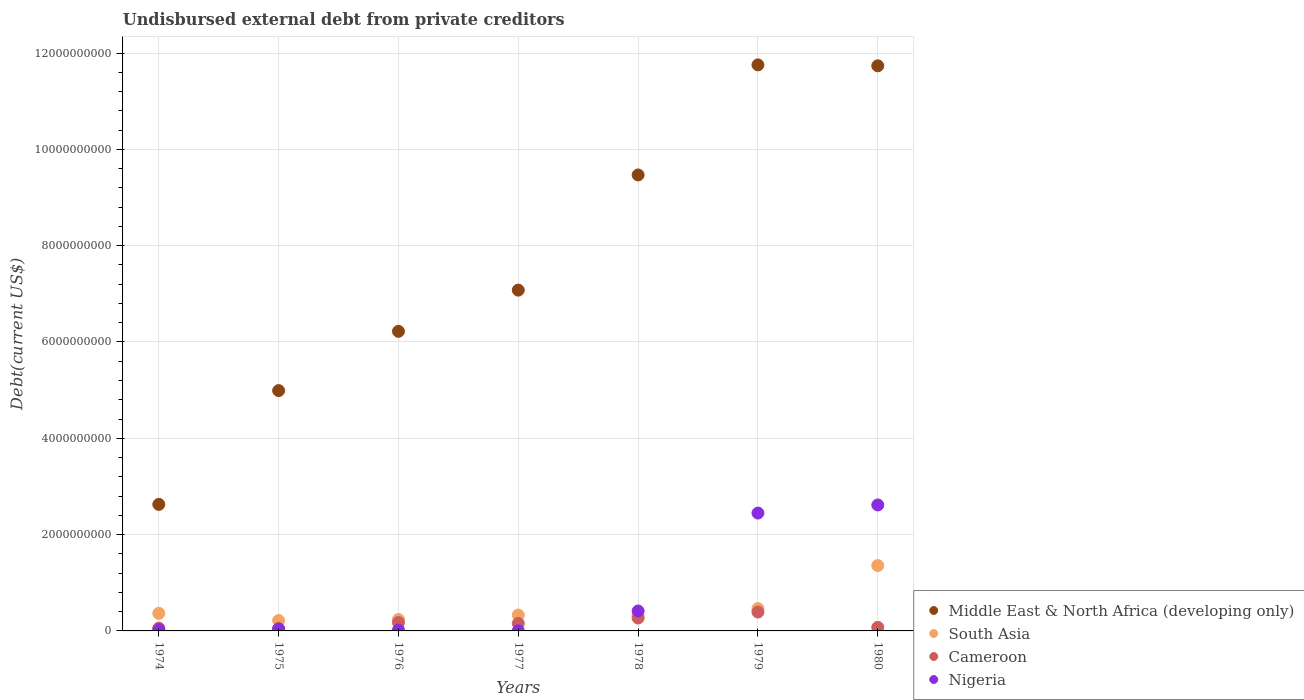How many different coloured dotlines are there?
Give a very brief answer. 4. Is the number of dotlines equal to the number of legend labels?
Ensure brevity in your answer.  Yes. What is the total debt in Cameroon in 1980?
Offer a terse response. 7.37e+07. Across all years, what is the maximum total debt in Cameroon?
Ensure brevity in your answer.  3.92e+08. Across all years, what is the minimum total debt in Middle East & North Africa (developing only)?
Offer a terse response. 2.63e+09. In which year was the total debt in Middle East & North Africa (developing only) maximum?
Provide a succinct answer. 1979. In which year was the total debt in Cameroon minimum?
Your answer should be very brief. 1975. What is the total total debt in Cameroon in the graph?
Your response must be concise. 1.17e+09. What is the difference between the total debt in Nigeria in 1978 and that in 1979?
Keep it short and to the point. -2.03e+09. What is the difference between the total debt in Nigeria in 1975 and the total debt in Cameroon in 1977?
Make the answer very short. -1.15e+08. What is the average total debt in Nigeria per year?
Offer a very short reply. 7.95e+08. In the year 1975, what is the difference between the total debt in Cameroon and total debt in Middle East & North Africa (developing only)?
Offer a terse response. -4.94e+09. In how many years, is the total debt in Nigeria greater than 8000000000 US$?
Your answer should be very brief. 0. What is the ratio of the total debt in Nigeria in 1975 to that in 1976?
Keep it short and to the point. 2.23. Is the total debt in Nigeria in 1976 less than that in 1977?
Give a very brief answer. No. What is the difference between the highest and the second highest total debt in Nigeria?
Keep it short and to the point. 1.69e+08. What is the difference between the highest and the lowest total debt in Middle East & North Africa (developing only)?
Offer a terse response. 9.13e+09. In how many years, is the total debt in South Asia greater than the average total debt in South Asia taken over all years?
Provide a succinct answer. 1. Is the sum of the total debt in Nigeria in 1977 and 1979 greater than the maximum total debt in Middle East & North Africa (developing only) across all years?
Your answer should be compact. No. Is it the case that in every year, the sum of the total debt in Cameroon and total debt in South Asia  is greater than the sum of total debt in Middle East & North Africa (developing only) and total debt in Nigeria?
Offer a terse response. No. Is the total debt in Cameroon strictly greater than the total debt in South Asia over the years?
Provide a short and direct response. No. How many dotlines are there?
Your answer should be very brief. 4. How many years are there in the graph?
Keep it short and to the point. 7. Are the values on the major ticks of Y-axis written in scientific E-notation?
Give a very brief answer. No. Does the graph contain any zero values?
Your response must be concise. No. Where does the legend appear in the graph?
Provide a succinct answer. Bottom right. How are the legend labels stacked?
Your answer should be compact. Vertical. What is the title of the graph?
Offer a very short reply. Undisbursed external debt from private creditors. Does "Uzbekistan" appear as one of the legend labels in the graph?
Provide a short and direct response. No. What is the label or title of the X-axis?
Offer a terse response. Years. What is the label or title of the Y-axis?
Give a very brief answer. Debt(current US$). What is the Debt(current US$) in Middle East & North Africa (developing only) in 1974?
Your answer should be very brief. 2.63e+09. What is the Debt(current US$) of South Asia in 1974?
Provide a succinct answer. 3.65e+08. What is the Debt(current US$) of Cameroon in 1974?
Give a very brief answer. 5.78e+07. What is the Debt(current US$) in Nigeria in 1974?
Ensure brevity in your answer.  2.52e+07. What is the Debt(current US$) in Middle East & North Africa (developing only) in 1975?
Provide a short and direct response. 4.99e+09. What is the Debt(current US$) of South Asia in 1975?
Offer a terse response. 2.15e+08. What is the Debt(current US$) of Cameroon in 1975?
Keep it short and to the point. 4.65e+07. What is the Debt(current US$) of Nigeria in 1975?
Your answer should be very brief. 4.00e+07. What is the Debt(current US$) of Middle East & North Africa (developing only) in 1976?
Offer a terse response. 6.22e+09. What is the Debt(current US$) in South Asia in 1976?
Give a very brief answer. 2.38e+08. What is the Debt(current US$) in Cameroon in 1976?
Give a very brief answer. 1.75e+08. What is the Debt(current US$) of Nigeria in 1976?
Offer a terse response. 1.80e+07. What is the Debt(current US$) of Middle East & North Africa (developing only) in 1977?
Your answer should be very brief. 7.08e+09. What is the Debt(current US$) of South Asia in 1977?
Keep it short and to the point. 3.30e+08. What is the Debt(current US$) in Cameroon in 1977?
Offer a very short reply. 1.55e+08. What is the Debt(current US$) in Nigeria in 1977?
Ensure brevity in your answer.  2.79e+06. What is the Debt(current US$) of Middle East & North Africa (developing only) in 1978?
Offer a very short reply. 9.47e+09. What is the Debt(current US$) in South Asia in 1978?
Keep it short and to the point. 3.08e+08. What is the Debt(current US$) of Cameroon in 1978?
Provide a short and direct response. 2.67e+08. What is the Debt(current US$) of Nigeria in 1978?
Ensure brevity in your answer.  4.14e+08. What is the Debt(current US$) of Middle East & North Africa (developing only) in 1979?
Your response must be concise. 1.18e+1. What is the Debt(current US$) in South Asia in 1979?
Offer a very short reply. 4.63e+08. What is the Debt(current US$) of Cameroon in 1979?
Make the answer very short. 3.92e+08. What is the Debt(current US$) in Nigeria in 1979?
Offer a terse response. 2.45e+09. What is the Debt(current US$) in Middle East & North Africa (developing only) in 1980?
Make the answer very short. 1.17e+1. What is the Debt(current US$) in South Asia in 1980?
Give a very brief answer. 1.36e+09. What is the Debt(current US$) in Cameroon in 1980?
Provide a short and direct response. 7.37e+07. What is the Debt(current US$) in Nigeria in 1980?
Offer a very short reply. 2.62e+09. Across all years, what is the maximum Debt(current US$) of Middle East & North Africa (developing only)?
Offer a very short reply. 1.18e+1. Across all years, what is the maximum Debt(current US$) in South Asia?
Provide a short and direct response. 1.36e+09. Across all years, what is the maximum Debt(current US$) of Cameroon?
Provide a succinct answer. 3.92e+08. Across all years, what is the maximum Debt(current US$) in Nigeria?
Make the answer very short. 2.62e+09. Across all years, what is the minimum Debt(current US$) of Middle East & North Africa (developing only)?
Ensure brevity in your answer.  2.63e+09. Across all years, what is the minimum Debt(current US$) of South Asia?
Offer a terse response. 2.15e+08. Across all years, what is the minimum Debt(current US$) in Cameroon?
Offer a very short reply. 4.65e+07. Across all years, what is the minimum Debt(current US$) of Nigeria?
Give a very brief answer. 2.79e+06. What is the total Debt(current US$) in Middle East & North Africa (developing only) in the graph?
Offer a very short reply. 5.39e+1. What is the total Debt(current US$) of South Asia in the graph?
Offer a very short reply. 3.28e+09. What is the total Debt(current US$) in Cameroon in the graph?
Keep it short and to the point. 1.17e+09. What is the total Debt(current US$) of Nigeria in the graph?
Keep it short and to the point. 5.56e+09. What is the difference between the Debt(current US$) in Middle East & North Africa (developing only) in 1974 and that in 1975?
Ensure brevity in your answer.  -2.36e+09. What is the difference between the Debt(current US$) of South Asia in 1974 and that in 1975?
Your answer should be compact. 1.50e+08. What is the difference between the Debt(current US$) in Cameroon in 1974 and that in 1975?
Offer a very short reply. 1.13e+07. What is the difference between the Debt(current US$) of Nigeria in 1974 and that in 1975?
Provide a succinct answer. -1.48e+07. What is the difference between the Debt(current US$) in Middle East & North Africa (developing only) in 1974 and that in 1976?
Provide a succinct answer. -3.59e+09. What is the difference between the Debt(current US$) in South Asia in 1974 and that in 1976?
Give a very brief answer. 1.27e+08. What is the difference between the Debt(current US$) in Cameroon in 1974 and that in 1976?
Provide a succinct answer. -1.17e+08. What is the difference between the Debt(current US$) of Nigeria in 1974 and that in 1976?
Provide a succinct answer. 7.27e+06. What is the difference between the Debt(current US$) of Middle East & North Africa (developing only) in 1974 and that in 1977?
Your answer should be compact. -4.45e+09. What is the difference between the Debt(current US$) in South Asia in 1974 and that in 1977?
Make the answer very short. 3.54e+07. What is the difference between the Debt(current US$) of Cameroon in 1974 and that in 1977?
Offer a terse response. -9.75e+07. What is the difference between the Debt(current US$) of Nigeria in 1974 and that in 1977?
Keep it short and to the point. 2.24e+07. What is the difference between the Debt(current US$) of Middle East & North Africa (developing only) in 1974 and that in 1978?
Offer a terse response. -6.84e+09. What is the difference between the Debt(current US$) of South Asia in 1974 and that in 1978?
Offer a very short reply. 5.73e+07. What is the difference between the Debt(current US$) in Cameroon in 1974 and that in 1978?
Offer a terse response. -2.09e+08. What is the difference between the Debt(current US$) of Nigeria in 1974 and that in 1978?
Your answer should be very brief. -3.89e+08. What is the difference between the Debt(current US$) in Middle East & North Africa (developing only) in 1974 and that in 1979?
Give a very brief answer. -9.13e+09. What is the difference between the Debt(current US$) in South Asia in 1974 and that in 1979?
Keep it short and to the point. -9.78e+07. What is the difference between the Debt(current US$) of Cameroon in 1974 and that in 1979?
Keep it short and to the point. -3.34e+08. What is the difference between the Debt(current US$) of Nigeria in 1974 and that in 1979?
Provide a succinct answer. -2.42e+09. What is the difference between the Debt(current US$) of Middle East & North Africa (developing only) in 1974 and that in 1980?
Provide a short and direct response. -9.11e+09. What is the difference between the Debt(current US$) in South Asia in 1974 and that in 1980?
Give a very brief answer. -9.92e+08. What is the difference between the Debt(current US$) of Cameroon in 1974 and that in 1980?
Make the answer very short. -1.59e+07. What is the difference between the Debt(current US$) of Nigeria in 1974 and that in 1980?
Offer a very short reply. -2.59e+09. What is the difference between the Debt(current US$) in Middle East & North Africa (developing only) in 1975 and that in 1976?
Keep it short and to the point. -1.23e+09. What is the difference between the Debt(current US$) in South Asia in 1975 and that in 1976?
Your response must be concise. -2.33e+07. What is the difference between the Debt(current US$) of Cameroon in 1975 and that in 1976?
Provide a short and direct response. -1.28e+08. What is the difference between the Debt(current US$) in Nigeria in 1975 and that in 1976?
Your answer should be compact. 2.21e+07. What is the difference between the Debt(current US$) in Middle East & North Africa (developing only) in 1975 and that in 1977?
Provide a short and direct response. -2.09e+09. What is the difference between the Debt(current US$) of South Asia in 1975 and that in 1977?
Give a very brief answer. -1.15e+08. What is the difference between the Debt(current US$) in Cameroon in 1975 and that in 1977?
Your response must be concise. -1.09e+08. What is the difference between the Debt(current US$) of Nigeria in 1975 and that in 1977?
Provide a short and direct response. 3.72e+07. What is the difference between the Debt(current US$) in Middle East & North Africa (developing only) in 1975 and that in 1978?
Offer a terse response. -4.48e+09. What is the difference between the Debt(current US$) in South Asia in 1975 and that in 1978?
Provide a succinct answer. -9.29e+07. What is the difference between the Debt(current US$) in Cameroon in 1975 and that in 1978?
Give a very brief answer. -2.20e+08. What is the difference between the Debt(current US$) of Nigeria in 1975 and that in 1978?
Give a very brief answer. -3.74e+08. What is the difference between the Debt(current US$) of Middle East & North Africa (developing only) in 1975 and that in 1979?
Offer a terse response. -6.76e+09. What is the difference between the Debt(current US$) in South Asia in 1975 and that in 1979?
Offer a very short reply. -2.48e+08. What is the difference between the Debt(current US$) of Cameroon in 1975 and that in 1979?
Make the answer very short. -3.46e+08. What is the difference between the Debt(current US$) of Nigeria in 1975 and that in 1979?
Provide a succinct answer. -2.41e+09. What is the difference between the Debt(current US$) in Middle East & North Africa (developing only) in 1975 and that in 1980?
Keep it short and to the point. -6.74e+09. What is the difference between the Debt(current US$) of South Asia in 1975 and that in 1980?
Make the answer very short. -1.14e+09. What is the difference between the Debt(current US$) in Cameroon in 1975 and that in 1980?
Your response must be concise. -2.72e+07. What is the difference between the Debt(current US$) of Nigeria in 1975 and that in 1980?
Provide a short and direct response. -2.58e+09. What is the difference between the Debt(current US$) of Middle East & North Africa (developing only) in 1976 and that in 1977?
Ensure brevity in your answer.  -8.55e+08. What is the difference between the Debt(current US$) of South Asia in 1976 and that in 1977?
Ensure brevity in your answer.  -9.15e+07. What is the difference between the Debt(current US$) of Cameroon in 1976 and that in 1977?
Ensure brevity in your answer.  1.94e+07. What is the difference between the Debt(current US$) in Nigeria in 1976 and that in 1977?
Offer a very short reply. 1.52e+07. What is the difference between the Debt(current US$) in Middle East & North Africa (developing only) in 1976 and that in 1978?
Your response must be concise. -3.25e+09. What is the difference between the Debt(current US$) of South Asia in 1976 and that in 1978?
Ensure brevity in your answer.  -6.96e+07. What is the difference between the Debt(current US$) of Cameroon in 1976 and that in 1978?
Ensure brevity in your answer.  -9.21e+07. What is the difference between the Debt(current US$) of Nigeria in 1976 and that in 1978?
Offer a very short reply. -3.96e+08. What is the difference between the Debt(current US$) in Middle East & North Africa (developing only) in 1976 and that in 1979?
Your answer should be compact. -5.53e+09. What is the difference between the Debt(current US$) of South Asia in 1976 and that in 1979?
Your answer should be compact. -2.25e+08. What is the difference between the Debt(current US$) in Cameroon in 1976 and that in 1979?
Give a very brief answer. -2.17e+08. What is the difference between the Debt(current US$) of Nigeria in 1976 and that in 1979?
Provide a short and direct response. -2.43e+09. What is the difference between the Debt(current US$) of Middle East & North Africa (developing only) in 1976 and that in 1980?
Provide a succinct answer. -5.51e+09. What is the difference between the Debt(current US$) in South Asia in 1976 and that in 1980?
Provide a succinct answer. -1.12e+09. What is the difference between the Debt(current US$) in Cameroon in 1976 and that in 1980?
Provide a succinct answer. 1.01e+08. What is the difference between the Debt(current US$) in Nigeria in 1976 and that in 1980?
Provide a short and direct response. -2.60e+09. What is the difference between the Debt(current US$) in Middle East & North Africa (developing only) in 1977 and that in 1978?
Offer a terse response. -2.39e+09. What is the difference between the Debt(current US$) of South Asia in 1977 and that in 1978?
Offer a very short reply. 2.19e+07. What is the difference between the Debt(current US$) in Cameroon in 1977 and that in 1978?
Offer a terse response. -1.12e+08. What is the difference between the Debt(current US$) in Nigeria in 1977 and that in 1978?
Give a very brief answer. -4.11e+08. What is the difference between the Debt(current US$) in Middle East & North Africa (developing only) in 1977 and that in 1979?
Ensure brevity in your answer.  -4.68e+09. What is the difference between the Debt(current US$) of South Asia in 1977 and that in 1979?
Offer a very short reply. -1.33e+08. What is the difference between the Debt(current US$) in Cameroon in 1977 and that in 1979?
Your response must be concise. -2.37e+08. What is the difference between the Debt(current US$) in Nigeria in 1977 and that in 1979?
Make the answer very short. -2.44e+09. What is the difference between the Debt(current US$) in Middle East & North Africa (developing only) in 1977 and that in 1980?
Your response must be concise. -4.66e+09. What is the difference between the Debt(current US$) of South Asia in 1977 and that in 1980?
Provide a short and direct response. -1.03e+09. What is the difference between the Debt(current US$) of Cameroon in 1977 and that in 1980?
Your answer should be very brief. 8.17e+07. What is the difference between the Debt(current US$) in Nigeria in 1977 and that in 1980?
Keep it short and to the point. -2.61e+09. What is the difference between the Debt(current US$) of Middle East & North Africa (developing only) in 1978 and that in 1979?
Provide a short and direct response. -2.29e+09. What is the difference between the Debt(current US$) in South Asia in 1978 and that in 1979?
Offer a terse response. -1.55e+08. What is the difference between the Debt(current US$) in Cameroon in 1978 and that in 1979?
Provide a succinct answer. -1.25e+08. What is the difference between the Debt(current US$) in Nigeria in 1978 and that in 1979?
Ensure brevity in your answer.  -2.03e+09. What is the difference between the Debt(current US$) in Middle East & North Africa (developing only) in 1978 and that in 1980?
Make the answer very short. -2.27e+09. What is the difference between the Debt(current US$) in South Asia in 1978 and that in 1980?
Make the answer very short. -1.05e+09. What is the difference between the Debt(current US$) of Cameroon in 1978 and that in 1980?
Provide a succinct answer. 1.93e+08. What is the difference between the Debt(current US$) of Nigeria in 1978 and that in 1980?
Your answer should be compact. -2.20e+09. What is the difference between the Debt(current US$) of Middle East & North Africa (developing only) in 1979 and that in 1980?
Make the answer very short. 1.97e+07. What is the difference between the Debt(current US$) in South Asia in 1979 and that in 1980?
Ensure brevity in your answer.  -8.94e+08. What is the difference between the Debt(current US$) in Cameroon in 1979 and that in 1980?
Keep it short and to the point. 3.18e+08. What is the difference between the Debt(current US$) in Nigeria in 1979 and that in 1980?
Your answer should be very brief. -1.69e+08. What is the difference between the Debt(current US$) of Middle East & North Africa (developing only) in 1974 and the Debt(current US$) of South Asia in 1975?
Your answer should be compact. 2.41e+09. What is the difference between the Debt(current US$) of Middle East & North Africa (developing only) in 1974 and the Debt(current US$) of Cameroon in 1975?
Offer a very short reply. 2.58e+09. What is the difference between the Debt(current US$) of Middle East & North Africa (developing only) in 1974 and the Debt(current US$) of Nigeria in 1975?
Provide a succinct answer. 2.59e+09. What is the difference between the Debt(current US$) in South Asia in 1974 and the Debt(current US$) in Cameroon in 1975?
Provide a short and direct response. 3.19e+08. What is the difference between the Debt(current US$) in South Asia in 1974 and the Debt(current US$) in Nigeria in 1975?
Give a very brief answer. 3.25e+08. What is the difference between the Debt(current US$) of Cameroon in 1974 and the Debt(current US$) of Nigeria in 1975?
Your answer should be compact. 1.78e+07. What is the difference between the Debt(current US$) of Middle East & North Africa (developing only) in 1974 and the Debt(current US$) of South Asia in 1976?
Your answer should be very brief. 2.39e+09. What is the difference between the Debt(current US$) in Middle East & North Africa (developing only) in 1974 and the Debt(current US$) in Cameroon in 1976?
Give a very brief answer. 2.45e+09. What is the difference between the Debt(current US$) in Middle East & North Africa (developing only) in 1974 and the Debt(current US$) in Nigeria in 1976?
Provide a short and direct response. 2.61e+09. What is the difference between the Debt(current US$) in South Asia in 1974 and the Debt(current US$) in Cameroon in 1976?
Your answer should be compact. 1.91e+08. What is the difference between the Debt(current US$) of South Asia in 1974 and the Debt(current US$) of Nigeria in 1976?
Ensure brevity in your answer.  3.47e+08. What is the difference between the Debt(current US$) in Cameroon in 1974 and the Debt(current US$) in Nigeria in 1976?
Your answer should be compact. 3.99e+07. What is the difference between the Debt(current US$) of Middle East & North Africa (developing only) in 1974 and the Debt(current US$) of South Asia in 1977?
Your response must be concise. 2.30e+09. What is the difference between the Debt(current US$) in Middle East & North Africa (developing only) in 1974 and the Debt(current US$) in Cameroon in 1977?
Provide a short and direct response. 2.47e+09. What is the difference between the Debt(current US$) in Middle East & North Africa (developing only) in 1974 and the Debt(current US$) in Nigeria in 1977?
Offer a very short reply. 2.62e+09. What is the difference between the Debt(current US$) of South Asia in 1974 and the Debt(current US$) of Cameroon in 1977?
Give a very brief answer. 2.10e+08. What is the difference between the Debt(current US$) in South Asia in 1974 and the Debt(current US$) in Nigeria in 1977?
Make the answer very short. 3.63e+08. What is the difference between the Debt(current US$) of Cameroon in 1974 and the Debt(current US$) of Nigeria in 1977?
Provide a succinct answer. 5.51e+07. What is the difference between the Debt(current US$) in Middle East & North Africa (developing only) in 1974 and the Debt(current US$) in South Asia in 1978?
Your response must be concise. 2.32e+09. What is the difference between the Debt(current US$) in Middle East & North Africa (developing only) in 1974 and the Debt(current US$) in Cameroon in 1978?
Provide a short and direct response. 2.36e+09. What is the difference between the Debt(current US$) in Middle East & North Africa (developing only) in 1974 and the Debt(current US$) in Nigeria in 1978?
Your answer should be compact. 2.21e+09. What is the difference between the Debt(current US$) in South Asia in 1974 and the Debt(current US$) in Cameroon in 1978?
Keep it short and to the point. 9.85e+07. What is the difference between the Debt(current US$) in South Asia in 1974 and the Debt(current US$) in Nigeria in 1978?
Give a very brief answer. -4.88e+07. What is the difference between the Debt(current US$) of Cameroon in 1974 and the Debt(current US$) of Nigeria in 1978?
Your answer should be compact. -3.56e+08. What is the difference between the Debt(current US$) of Middle East & North Africa (developing only) in 1974 and the Debt(current US$) of South Asia in 1979?
Offer a very short reply. 2.16e+09. What is the difference between the Debt(current US$) in Middle East & North Africa (developing only) in 1974 and the Debt(current US$) in Cameroon in 1979?
Keep it short and to the point. 2.24e+09. What is the difference between the Debt(current US$) of Middle East & North Africa (developing only) in 1974 and the Debt(current US$) of Nigeria in 1979?
Provide a short and direct response. 1.80e+08. What is the difference between the Debt(current US$) in South Asia in 1974 and the Debt(current US$) in Cameroon in 1979?
Make the answer very short. -2.68e+07. What is the difference between the Debt(current US$) in South Asia in 1974 and the Debt(current US$) in Nigeria in 1979?
Make the answer very short. -2.08e+09. What is the difference between the Debt(current US$) in Cameroon in 1974 and the Debt(current US$) in Nigeria in 1979?
Ensure brevity in your answer.  -2.39e+09. What is the difference between the Debt(current US$) of Middle East & North Africa (developing only) in 1974 and the Debt(current US$) of South Asia in 1980?
Your answer should be very brief. 1.27e+09. What is the difference between the Debt(current US$) of Middle East & North Africa (developing only) in 1974 and the Debt(current US$) of Cameroon in 1980?
Offer a very short reply. 2.55e+09. What is the difference between the Debt(current US$) of Middle East & North Africa (developing only) in 1974 and the Debt(current US$) of Nigeria in 1980?
Provide a short and direct response. 1.20e+07. What is the difference between the Debt(current US$) of South Asia in 1974 and the Debt(current US$) of Cameroon in 1980?
Ensure brevity in your answer.  2.92e+08. What is the difference between the Debt(current US$) of South Asia in 1974 and the Debt(current US$) of Nigeria in 1980?
Make the answer very short. -2.25e+09. What is the difference between the Debt(current US$) in Cameroon in 1974 and the Debt(current US$) in Nigeria in 1980?
Offer a very short reply. -2.56e+09. What is the difference between the Debt(current US$) in Middle East & North Africa (developing only) in 1975 and the Debt(current US$) in South Asia in 1976?
Your answer should be very brief. 4.75e+09. What is the difference between the Debt(current US$) of Middle East & North Africa (developing only) in 1975 and the Debt(current US$) of Cameroon in 1976?
Your response must be concise. 4.82e+09. What is the difference between the Debt(current US$) in Middle East & North Africa (developing only) in 1975 and the Debt(current US$) in Nigeria in 1976?
Give a very brief answer. 4.97e+09. What is the difference between the Debt(current US$) of South Asia in 1975 and the Debt(current US$) of Cameroon in 1976?
Your response must be concise. 4.04e+07. What is the difference between the Debt(current US$) of South Asia in 1975 and the Debt(current US$) of Nigeria in 1976?
Your response must be concise. 1.97e+08. What is the difference between the Debt(current US$) of Cameroon in 1975 and the Debt(current US$) of Nigeria in 1976?
Your response must be concise. 2.85e+07. What is the difference between the Debt(current US$) of Middle East & North Africa (developing only) in 1975 and the Debt(current US$) of South Asia in 1977?
Provide a short and direct response. 4.66e+09. What is the difference between the Debt(current US$) in Middle East & North Africa (developing only) in 1975 and the Debt(current US$) in Cameroon in 1977?
Keep it short and to the point. 4.83e+09. What is the difference between the Debt(current US$) in Middle East & North Africa (developing only) in 1975 and the Debt(current US$) in Nigeria in 1977?
Provide a short and direct response. 4.99e+09. What is the difference between the Debt(current US$) of South Asia in 1975 and the Debt(current US$) of Cameroon in 1977?
Your answer should be compact. 5.98e+07. What is the difference between the Debt(current US$) in South Asia in 1975 and the Debt(current US$) in Nigeria in 1977?
Your answer should be very brief. 2.12e+08. What is the difference between the Debt(current US$) of Cameroon in 1975 and the Debt(current US$) of Nigeria in 1977?
Offer a very short reply. 4.37e+07. What is the difference between the Debt(current US$) of Middle East & North Africa (developing only) in 1975 and the Debt(current US$) of South Asia in 1978?
Ensure brevity in your answer.  4.68e+09. What is the difference between the Debt(current US$) of Middle East & North Africa (developing only) in 1975 and the Debt(current US$) of Cameroon in 1978?
Give a very brief answer. 4.72e+09. What is the difference between the Debt(current US$) in Middle East & North Africa (developing only) in 1975 and the Debt(current US$) in Nigeria in 1978?
Give a very brief answer. 4.58e+09. What is the difference between the Debt(current US$) of South Asia in 1975 and the Debt(current US$) of Cameroon in 1978?
Your response must be concise. -5.18e+07. What is the difference between the Debt(current US$) of South Asia in 1975 and the Debt(current US$) of Nigeria in 1978?
Make the answer very short. -1.99e+08. What is the difference between the Debt(current US$) of Cameroon in 1975 and the Debt(current US$) of Nigeria in 1978?
Your answer should be very brief. -3.68e+08. What is the difference between the Debt(current US$) in Middle East & North Africa (developing only) in 1975 and the Debt(current US$) in South Asia in 1979?
Offer a very short reply. 4.53e+09. What is the difference between the Debt(current US$) of Middle East & North Africa (developing only) in 1975 and the Debt(current US$) of Cameroon in 1979?
Your response must be concise. 4.60e+09. What is the difference between the Debt(current US$) in Middle East & North Africa (developing only) in 1975 and the Debt(current US$) in Nigeria in 1979?
Your answer should be very brief. 2.54e+09. What is the difference between the Debt(current US$) of South Asia in 1975 and the Debt(current US$) of Cameroon in 1979?
Your answer should be compact. -1.77e+08. What is the difference between the Debt(current US$) in South Asia in 1975 and the Debt(current US$) in Nigeria in 1979?
Keep it short and to the point. -2.23e+09. What is the difference between the Debt(current US$) of Cameroon in 1975 and the Debt(current US$) of Nigeria in 1979?
Offer a terse response. -2.40e+09. What is the difference between the Debt(current US$) of Middle East & North Africa (developing only) in 1975 and the Debt(current US$) of South Asia in 1980?
Provide a succinct answer. 3.63e+09. What is the difference between the Debt(current US$) in Middle East & North Africa (developing only) in 1975 and the Debt(current US$) in Cameroon in 1980?
Offer a terse response. 4.92e+09. What is the difference between the Debt(current US$) of Middle East & North Africa (developing only) in 1975 and the Debt(current US$) of Nigeria in 1980?
Make the answer very short. 2.37e+09. What is the difference between the Debt(current US$) in South Asia in 1975 and the Debt(current US$) in Cameroon in 1980?
Provide a short and direct response. 1.41e+08. What is the difference between the Debt(current US$) in South Asia in 1975 and the Debt(current US$) in Nigeria in 1980?
Give a very brief answer. -2.40e+09. What is the difference between the Debt(current US$) in Cameroon in 1975 and the Debt(current US$) in Nigeria in 1980?
Your answer should be very brief. -2.57e+09. What is the difference between the Debt(current US$) in Middle East & North Africa (developing only) in 1976 and the Debt(current US$) in South Asia in 1977?
Ensure brevity in your answer.  5.89e+09. What is the difference between the Debt(current US$) in Middle East & North Africa (developing only) in 1976 and the Debt(current US$) in Cameroon in 1977?
Your answer should be very brief. 6.07e+09. What is the difference between the Debt(current US$) in Middle East & North Africa (developing only) in 1976 and the Debt(current US$) in Nigeria in 1977?
Your response must be concise. 6.22e+09. What is the difference between the Debt(current US$) in South Asia in 1976 and the Debt(current US$) in Cameroon in 1977?
Give a very brief answer. 8.31e+07. What is the difference between the Debt(current US$) in South Asia in 1976 and the Debt(current US$) in Nigeria in 1977?
Provide a succinct answer. 2.36e+08. What is the difference between the Debt(current US$) of Cameroon in 1976 and the Debt(current US$) of Nigeria in 1977?
Keep it short and to the point. 1.72e+08. What is the difference between the Debt(current US$) of Middle East & North Africa (developing only) in 1976 and the Debt(current US$) of South Asia in 1978?
Provide a succinct answer. 5.91e+09. What is the difference between the Debt(current US$) in Middle East & North Africa (developing only) in 1976 and the Debt(current US$) in Cameroon in 1978?
Provide a succinct answer. 5.95e+09. What is the difference between the Debt(current US$) of Middle East & North Africa (developing only) in 1976 and the Debt(current US$) of Nigeria in 1978?
Ensure brevity in your answer.  5.81e+09. What is the difference between the Debt(current US$) of South Asia in 1976 and the Debt(current US$) of Cameroon in 1978?
Your answer should be very brief. -2.84e+07. What is the difference between the Debt(current US$) of South Asia in 1976 and the Debt(current US$) of Nigeria in 1978?
Your response must be concise. -1.76e+08. What is the difference between the Debt(current US$) in Cameroon in 1976 and the Debt(current US$) in Nigeria in 1978?
Your response must be concise. -2.39e+08. What is the difference between the Debt(current US$) in Middle East & North Africa (developing only) in 1976 and the Debt(current US$) in South Asia in 1979?
Your answer should be compact. 5.76e+09. What is the difference between the Debt(current US$) of Middle East & North Africa (developing only) in 1976 and the Debt(current US$) of Cameroon in 1979?
Keep it short and to the point. 5.83e+09. What is the difference between the Debt(current US$) in Middle East & North Africa (developing only) in 1976 and the Debt(current US$) in Nigeria in 1979?
Give a very brief answer. 3.77e+09. What is the difference between the Debt(current US$) in South Asia in 1976 and the Debt(current US$) in Cameroon in 1979?
Your response must be concise. -1.54e+08. What is the difference between the Debt(current US$) in South Asia in 1976 and the Debt(current US$) in Nigeria in 1979?
Provide a succinct answer. -2.21e+09. What is the difference between the Debt(current US$) of Cameroon in 1976 and the Debt(current US$) of Nigeria in 1979?
Your answer should be very brief. -2.27e+09. What is the difference between the Debt(current US$) in Middle East & North Africa (developing only) in 1976 and the Debt(current US$) in South Asia in 1980?
Your answer should be compact. 4.86e+09. What is the difference between the Debt(current US$) in Middle East & North Africa (developing only) in 1976 and the Debt(current US$) in Cameroon in 1980?
Offer a very short reply. 6.15e+09. What is the difference between the Debt(current US$) in Middle East & North Africa (developing only) in 1976 and the Debt(current US$) in Nigeria in 1980?
Offer a very short reply. 3.61e+09. What is the difference between the Debt(current US$) in South Asia in 1976 and the Debt(current US$) in Cameroon in 1980?
Provide a short and direct response. 1.65e+08. What is the difference between the Debt(current US$) of South Asia in 1976 and the Debt(current US$) of Nigeria in 1980?
Ensure brevity in your answer.  -2.38e+09. What is the difference between the Debt(current US$) in Cameroon in 1976 and the Debt(current US$) in Nigeria in 1980?
Provide a succinct answer. -2.44e+09. What is the difference between the Debt(current US$) of Middle East & North Africa (developing only) in 1977 and the Debt(current US$) of South Asia in 1978?
Make the answer very short. 6.77e+09. What is the difference between the Debt(current US$) of Middle East & North Africa (developing only) in 1977 and the Debt(current US$) of Cameroon in 1978?
Provide a succinct answer. 6.81e+09. What is the difference between the Debt(current US$) in Middle East & North Africa (developing only) in 1977 and the Debt(current US$) in Nigeria in 1978?
Provide a succinct answer. 6.66e+09. What is the difference between the Debt(current US$) of South Asia in 1977 and the Debt(current US$) of Cameroon in 1978?
Your answer should be very brief. 6.31e+07. What is the difference between the Debt(current US$) of South Asia in 1977 and the Debt(current US$) of Nigeria in 1978?
Your answer should be compact. -8.42e+07. What is the difference between the Debt(current US$) in Cameroon in 1977 and the Debt(current US$) in Nigeria in 1978?
Offer a very short reply. -2.59e+08. What is the difference between the Debt(current US$) of Middle East & North Africa (developing only) in 1977 and the Debt(current US$) of South Asia in 1979?
Your answer should be compact. 6.61e+09. What is the difference between the Debt(current US$) of Middle East & North Africa (developing only) in 1977 and the Debt(current US$) of Cameroon in 1979?
Your response must be concise. 6.68e+09. What is the difference between the Debt(current US$) in Middle East & North Africa (developing only) in 1977 and the Debt(current US$) in Nigeria in 1979?
Ensure brevity in your answer.  4.63e+09. What is the difference between the Debt(current US$) of South Asia in 1977 and the Debt(current US$) of Cameroon in 1979?
Provide a succinct answer. -6.22e+07. What is the difference between the Debt(current US$) of South Asia in 1977 and the Debt(current US$) of Nigeria in 1979?
Offer a terse response. -2.12e+09. What is the difference between the Debt(current US$) in Cameroon in 1977 and the Debt(current US$) in Nigeria in 1979?
Keep it short and to the point. -2.29e+09. What is the difference between the Debt(current US$) of Middle East & North Africa (developing only) in 1977 and the Debt(current US$) of South Asia in 1980?
Your answer should be very brief. 5.72e+09. What is the difference between the Debt(current US$) in Middle East & North Africa (developing only) in 1977 and the Debt(current US$) in Cameroon in 1980?
Ensure brevity in your answer.  7.00e+09. What is the difference between the Debt(current US$) in Middle East & North Africa (developing only) in 1977 and the Debt(current US$) in Nigeria in 1980?
Your answer should be compact. 4.46e+09. What is the difference between the Debt(current US$) of South Asia in 1977 and the Debt(current US$) of Cameroon in 1980?
Your response must be concise. 2.56e+08. What is the difference between the Debt(current US$) of South Asia in 1977 and the Debt(current US$) of Nigeria in 1980?
Make the answer very short. -2.29e+09. What is the difference between the Debt(current US$) in Cameroon in 1977 and the Debt(current US$) in Nigeria in 1980?
Ensure brevity in your answer.  -2.46e+09. What is the difference between the Debt(current US$) in Middle East & North Africa (developing only) in 1978 and the Debt(current US$) in South Asia in 1979?
Give a very brief answer. 9.00e+09. What is the difference between the Debt(current US$) in Middle East & North Africa (developing only) in 1978 and the Debt(current US$) in Cameroon in 1979?
Make the answer very short. 9.08e+09. What is the difference between the Debt(current US$) of Middle East & North Africa (developing only) in 1978 and the Debt(current US$) of Nigeria in 1979?
Make the answer very short. 7.02e+09. What is the difference between the Debt(current US$) in South Asia in 1978 and the Debt(current US$) in Cameroon in 1979?
Your answer should be compact. -8.41e+07. What is the difference between the Debt(current US$) in South Asia in 1978 and the Debt(current US$) in Nigeria in 1979?
Keep it short and to the point. -2.14e+09. What is the difference between the Debt(current US$) of Cameroon in 1978 and the Debt(current US$) of Nigeria in 1979?
Offer a terse response. -2.18e+09. What is the difference between the Debt(current US$) in Middle East & North Africa (developing only) in 1978 and the Debt(current US$) in South Asia in 1980?
Provide a succinct answer. 8.11e+09. What is the difference between the Debt(current US$) in Middle East & North Africa (developing only) in 1978 and the Debt(current US$) in Cameroon in 1980?
Ensure brevity in your answer.  9.39e+09. What is the difference between the Debt(current US$) in Middle East & North Africa (developing only) in 1978 and the Debt(current US$) in Nigeria in 1980?
Offer a terse response. 6.85e+09. What is the difference between the Debt(current US$) of South Asia in 1978 and the Debt(current US$) of Cameroon in 1980?
Keep it short and to the point. 2.34e+08. What is the difference between the Debt(current US$) of South Asia in 1978 and the Debt(current US$) of Nigeria in 1980?
Offer a very short reply. -2.31e+09. What is the difference between the Debt(current US$) in Cameroon in 1978 and the Debt(current US$) in Nigeria in 1980?
Ensure brevity in your answer.  -2.35e+09. What is the difference between the Debt(current US$) of Middle East & North Africa (developing only) in 1979 and the Debt(current US$) of South Asia in 1980?
Ensure brevity in your answer.  1.04e+1. What is the difference between the Debt(current US$) of Middle East & North Africa (developing only) in 1979 and the Debt(current US$) of Cameroon in 1980?
Make the answer very short. 1.17e+1. What is the difference between the Debt(current US$) of Middle East & North Africa (developing only) in 1979 and the Debt(current US$) of Nigeria in 1980?
Your answer should be compact. 9.14e+09. What is the difference between the Debt(current US$) of South Asia in 1979 and the Debt(current US$) of Cameroon in 1980?
Provide a succinct answer. 3.90e+08. What is the difference between the Debt(current US$) of South Asia in 1979 and the Debt(current US$) of Nigeria in 1980?
Your answer should be compact. -2.15e+09. What is the difference between the Debt(current US$) of Cameroon in 1979 and the Debt(current US$) of Nigeria in 1980?
Keep it short and to the point. -2.22e+09. What is the average Debt(current US$) in Middle East & North Africa (developing only) per year?
Offer a terse response. 7.70e+09. What is the average Debt(current US$) of South Asia per year?
Your answer should be compact. 4.68e+08. What is the average Debt(current US$) in Cameroon per year?
Your response must be concise. 1.67e+08. What is the average Debt(current US$) of Nigeria per year?
Provide a short and direct response. 7.95e+08. In the year 1974, what is the difference between the Debt(current US$) in Middle East & North Africa (developing only) and Debt(current US$) in South Asia?
Provide a short and direct response. 2.26e+09. In the year 1974, what is the difference between the Debt(current US$) in Middle East & North Africa (developing only) and Debt(current US$) in Cameroon?
Your answer should be very brief. 2.57e+09. In the year 1974, what is the difference between the Debt(current US$) of Middle East & North Africa (developing only) and Debt(current US$) of Nigeria?
Offer a terse response. 2.60e+09. In the year 1974, what is the difference between the Debt(current US$) of South Asia and Debt(current US$) of Cameroon?
Your answer should be compact. 3.08e+08. In the year 1974, what is the difference between the Debt(current US$) in South Asia and Debt(current US$) in Nigeria?
Offer a terse response. 3.40e+08. In the year 1974, what is the difference between the Debt(current US$) in Cameroon and Debt(current US$) in Nigeria?
Your answer should be very brief. 3.26e+07. In the year 1975, what is the difference between the Debt(current US$) in Middle East & North Africa (developing only) and Debt(current US$) in South Asia?
Ensure brevity in your answer.  4.77e+09. In the year 1975, what is the difference between the Debt(current US$) of Middle East & North Africa (developing only) and Debt(current US$) of Cameroon?
Give a very brief answer. 4.94e+09. In the year 1975, what is the difference between the Debt(current US$) of Middle East & North Africa (developing only) and Debt(current US$) of Nigeria?
Your answer should be very brief. 4.95e+09. In the year 1975, what is the difference between the Debt(current US$) of South Asia and Debt(current US$) of Cameroon?
Offer a terse response. 1.69e+08. In the year 1975, what is the difference between the Debt(current US$) in South Asia and Debt(current US$) in Nigeria?
Give a very brief answer. 1.75e+08. In the year 1975, what is the difference between the Debt(current US$) of Cameroon and Debt(current US$) of Nigeria?
Your answer should be very brief. 6.48e+06. In the year 1976, what is the difference between the Debt(current US$) of Middle East & North Africa (developing only) and Debt(current US$) of South Asia?
Offer a very short reply. 5.98e+09. In the year 1976, what is the difference between the Debt(current US$) in Middle East & North Africa (developing only) and Debt(current US$) in Cameroon?
Your response must be concise. 6.05e+09. In the year 1976, what is the difference between the Debt(current US$) in Middle East & North Africa (developing only) and Debt(current US$) in Nigeria?
Your answer should be compact. 6.20e+09. In the year 1976, what is the difference between the Debt(current US$) of South Asia and Debt(current US$) of Cameroon?
Ensure brevity in your answer.  6.37e+07. In the year 1976, what is the difference between the Debt(current US$) of South Asia and Debt(current US$) of Nigeria?
Your response must be concise. 2.21e+08. In the year 1976, what is the difference between the Debt(current US$) in Cameroon and Debt(current US$) in Nigeria?
Your answer should be compact. 1.57e+08. In the year 1977, what is the difference between the Debt(current US$) in Middle East & North Africa (developing only) and Debt(current US$) in South Asia?
Make the answer very short. 6.75e+09. In the year 1977, what is the difference between the Debt(current US$) in Middle East & North Africa (developing only) and Debt(current US$) in Cameroon?
Keep it short and to the point. 6.92e+09. In the year 1977, what is the difference between the Debt(current US$) of Middle East & North Africa (developing only) and Debt(current US$) of Nigeria?
Make the answer very short. 7.07e+09. In the year 1977, what is the difference between the Debt(current US$) of South Asia and Debt(current US$) of Cameroon?
Keep it short and to the point. 1.75e+08. In the year 1977, what is the difference between the Debt(current US$) in South Asia and Debt(current US$) in Nigeria?
Your answer should be compact. 3.27e+08. In the year 1977, what is the difference between the Debt(current US$) of Cameroon and Debt(current US$) of Nigeria?
Provide a succinct answer. 1.53e+08. In the year 1978, what is the difference between the Debt(current US$) in Middle East & North Africa (developing only) and Debt(current US$) in South Asia?
Offer a terse response. 9.16e+09. In the year 1978, what is the difference between the Debt(current US$) in Middle East & North Africa (developing only) and Debt(current US$) in Cameroon?
Offer a terse response. 9.20e+09. In the year 1978, what is the difference between the Debt(current US$) in Middle East & North Africa (developing only) and Debt(current US$) in Nigeria?
Ensure brevity in your answer.  9.05e+09. In the year 1978, what is the difference between the Debt(current US$) of South Asia and Debt(current US$) of Cameroon?
Provide a succinct answer. 4.12e+07. In the year 1978, what is the difference between the Debt(current US$) in South Asia and Debt(current US$) in Nigeria?
Ensure brevity in your answer.  -1.06e+08. In the year 1978, what is the difference between the Debt(current US$) in Cameroon and Debt(current US$) in Nigeria?
Offer a very short reply. -1.47e+08. In the year 1979, what is the difference between the Debt(current US$) in Middle East & North Africa (developing only) and Debt(current US$) in South Asia?
Keep it short and to the point. 1.13e+1. In the year 1979, what is the difference between the Debt(current US$) in Middle East & North Africa (developing only) and Debt(current US$) in Cameroon?
Your answer should be compact. 1.14e+1. In the year 1979, what is the difference between the Debt(current US$) of Middle East & North Africa (developing only) and Debt(current US$) of Nigeria?
Your answer should be compact. 9.31e+09. In the year 1979, what is the difference between the Debt(current US$) in South Asia and Debt(current US$) in Cameroon?
Your response must be concise. 7.11e+07. In the year 1979, what is the difference between the Debt(current US$) in South Asia and Debt(current US$) in Nigeria?
Keep it short and to the point. -1.98e+09. In the year 1979, what is the difference between the Debt(current US$) of Cameroon and Debt(current US$) of Nigeria?
Offer a terse response. -2.05e+09. In the year 1980, what is the difference between the Debt(current US$) of Middle East & North Africa (developing only) and Debt(current US$) of South Asia?
Provide a succinct answer. 1.04e+1. In the year 1980, what is the difference between the Debt(current US$) of Middle East & North Africa (developing only) and Debt(current US$) of Cameroon?
Ensure brevity in your answer.  1.17e+1. In the year 1980, what is the difference between the Debt(current US$) in Middle East & North Africa (developing only) and Debt(current US$) in Nigeria?
Keep it short and to the point. 9.12e+09. In the year 1980, what is the difference between the Debt(current US$) of South Asia and Debt(current US$) of Cameroon?
Offer a very short reply. 1.28e+09. In the year 1980, what is the difference between the Debt(current US$) in South Asia and Debt(current US$) in Nigeria?
Make the answer very short. -1.26e+09. In the year 1980, what is the difference between the Debt(current US$) in Cameroon and Debt(current US$) in Nigeria?
Offer a terse response. -2.54e+09. What is the ratio of the Debt(current US$) of Middle East & North Africa (developing only) in 1974 to that in 1975?
Provide a succinct answer. 0.53. What is the ratio of the Debt(current US$) in South Asia in 1974 to that in 1975?
Provide a succinct answer. 1.7. What is the ratio of the Debt(current US$) in Cameroon in 1974 to that in 1975?
Offer a very short reply. 1.24. What is the ratio of the Debt(current US$) of Nigeria in 1974 to that in 1975?
Your answer should be very brief. 0.63. What is the ratio of the Debt(current US$) of Middle East & North Africa (developing only) in 1974 to that in 1976?
Ensure brevity in your answer.  0.42. What is the ratio of the Debt(current US$) in South Asia in 1974 to that in 1976?
Provide a short and direct response. 1.53. What is the ratio of the Debt(current US$) of Cameroon in 1974 to that in 1976?
Provide a short and direct response. 0.33. What is the ratio of the Debt(current US$) of Nigeria in 1974 to that in 1976?
Give a very brief answer. 1.41. What is the ratio of the Debt(current US$) in Middle East & North Africa (developing only) in 1974 to that in 1977?
Your answer should be very brief. 0.37. What is the ratio of the Debt(current US$) in South Asia in 1974 to that in 1977?
Ensure brevity in your answer.  1.11. What is the ratio of the Debt(current US$) of Cameroon in 1974 to that in 1977?
Your answer should be compact. 0.37. What is the ratio of the Debt(current US$) in Nigeria in 1974 to that in 1977?
Your response must be concise. 9.06. What is the ratio of the Debt(current US$) in Middle East & North Africa (developing only) in 1974 to that in 1978?
Your answer should be compact. 0.28. What is the ratio of the Debt(current US$) in South Asia in 1974 to that in 1978?
Provide a succinct answer. 1.19. What is the ratio of the Debt(current US$) of Cameroon in 1974 to that in 1978?
Offer a very short reply. 0.22. What is the ratio of the Debt(current US$) in Nigeria in 1974 to that in 1978?
Offer a terse response. 0.06. What is the ratio of the Debt(current US$) in Middle East & North Africa (developing only) in 1974 to that in 1979?
Give a very brief answer. 0.22. What is the ratio of the Debt(current US$) in South Asia in 1974 to that in 1979?
Provide a short and direct response. 0.79. What is the ratio of the Debt(current US$) of Cameroon in 1974 to that in 1979?
Keep it short and to the point. 0.15. What is the ratio of the Debt(current US$) of Nigeria in 1974 to that in 1979?
Offer a terse response. 0.01. What is the ratio of the Debt(current US$) of Middle East & North Africa (developing only) in 1974 to that in 1980?
Your response must be concise. 0.22. What is the ratio of the Debt(current US$) in South Asia in 1974 to that in 1980?
Provide a succinct answer. 0.27. What is the ratio of the Debt(current US$) in Cameroon in 1974 to that in 1980?
Keep it short and to the point. 0.78. What is the ratio of the Debt(current US$) of Nigeria in 1974 to that in 1980?
Provide a succinct answer. 0.01. What is the ratio of the Debt(current US$) of Middle East & North Africa (developing only) in 1975 to that in 1976?
Provide a short and direct response. 0.8. What is the ratio of the Debt(current US$) in South Asia in 1975 to that in 1976?
Keep it short and to the point. 0.9. What is the ratio of the Debt(current US$) of Cameroon in 1975 to that in 1976?
Ensure brevity in your answer.  0.27. What is the ratio of the Debt(current US$) of Nigeria in 1975 to that in 1976?
Give a very brief answer. 2.23. What is the ratio of the Debt(current US$) of Middle East & North Africa (developing only) in 1975 to that in 1977?
Keep it short and to the point. 0.71. What is the ratio of the Debt(current US$) in South Asia in 1975 to that in 1977?
Keep it short and to the point. 0.65. What is the ratio of the Debt(current US$) of Cameroon in 1975 to that in 1977?
Keep it short and to the point. 0.3. What is the ratio of the Debt(current US$) of Nigeria in 1975 to that in 1977?
Make the answer very short. 14.37. What is the ratio of the Debt(current US$) of Middle East & North Africa (developing only) in 1975 to that in 1978?
Your response must be concise. 0.53. What is the ratio of the Debt(current US$) in South Asia in 1975 to that in 1978?
Ensure brevity in your answer.  0.7. What is the ratio of the Debt(current US$) in Cameroon in 1975 to that in 1978?
Make the answer very short. 0.17. What is the ratio of the Debt(current US$) of Nigeria in 1975 to that in 1978?
Provide a succinct answer. 0.1. What is the ratio of the Debt(current US$) in Middle East & North Africa (developing only) in 1975 to that in 1979?
Make the answer very short. 0.42. What is the ratio of the Debt(current US$) in South Asia in 1975 to that in 1979?
Keep it short and to the point. 0.46. What is the ratio of the Debt(current US$) of Cameroon in 1975 to that in 1979?
Offer a terse response. 0.12. What is the ratio of the Debt(current US$) in Nigeria in 1975 to that in 1979?
Provide a succinct answer. 0.02. What is the ratio of the Debt(current US$) in Middle East & North Africa (developing only) in 1975 to that in 1980?
Provide a short and direct response. 0.43. What is the ratio of the Debt(current US$) in South Asia in 1975 to that in 1980?
Provide a succinct answer. 0.16. What is the ratio of the Debt(current US$) of Cameroon in 1975 to that in 1980?
Offer a terse response. 0.63. What is the ratio of the Debt(current US$) in Nigeria in 1975 to that in 1980?
Your response must be concise. 0.02. What is the ratio of the Debt(current US$) in Middle East & North Africa (developing only) in 1976 to that in 1977?
Keep it short and to the point. 0.88. What is the ratio of the Debt(current US$) of South Asia in 1976 to that in 1977?
Ensure brevity in your answer.  0.72. What is the ratio of the Debt(current US$) in Cameroon in 1976 to that in 1977?
Keep it short and to the point. 1.13. What is the ratio of the Debt(current US$) of Nigeria in 1976 to that in 1977?
Your answer should be very brief. 6.45. What is the ratio of the Debt(current US$) of Middle East & North Africa (developing only) in 1976 to that in 1978?
Offer a terse response. 0.66. What is the ratio of the Debt(current US$) in South Asia in 1976 to that in 1978?
Offer a very short reply. 0.77. What is the ratio of the Debt(current US$) of Cameroon in 1976 to that in 1978?
Give a very brief answer. 0.65. What is the ratio of the Debt(current US$) of Nigeria in 1976 to that in 1978?
Provide a succinct answer. 0.04. What is the ratio of the Debt(current US$) of Middle East & North Africa (developing only) in 1976 to that in 1979?
Provide a succinct answer. 0.53. What is the ratio of the Debt(current US$) in South Asia in 1976 to that in 1979?
Keep it short and to the point. 0.51. What is the ratio of the Debt(current US$) in Cameroon in 1976 to that in 1979?
Your answer should be very brief. 0.45. What is the ratio of the Debt(current US$) in Nigeria in 1976 to that in 1979?
Make the answer very short. 0.01. What is the ratio of the Debt(current US$) of Middle East & North Africa (developing only) in 1976 to that in 1980?
Keep it short and to the point. 0.53. What is the ratio of the Debt(current US$) of South Asia in 1976 to that in 1980?
Make the answer very short. 0.18. What is the ratio of the Debt(current US$) of Cameroon in 1976 to that in 1980?
Make the answer very short. 2.37. What is the ratio of the Debt(current US$) of Nigeria in 1976 to that in 1980?
Offer a terse response. 0.01. What is the ratio of the Debt(current US$) in Middle East & North Africa (developing only) in 1977 to that in 1978?
Offer a very short reply. 0.75. What is the ratio of the Debt(current US$) of South Asia in 1977 to that in 1978?
Give a very brief answer. 1.07. What is the ratio of the Debt(current US$) in Cameroon in 1977 to that in 1978?
Make the answer very short. 0.58. What is the ratio of the Debt(current US$) in Nigeria in 1977 to that in 1978?
Provide a short and direct response. 0.01. What is the ratio of the Debt(current US$) in Middle East & North Africa (developing only) in 1977 to that in 1979?
Provide a succinct answer. 0.6. What is the ratio of the Debt(current US$) in South Asia in 1977 to that in 1979?
Provide a short and direct response. 0.71. What is the ratio of the Debt(current US$) in Cameroon in 1977 to that in 1979?
Offer a very short reply. 0.4. What is the ratio of the Debt(current US$) in Nigeria in 1977 to that in 1979?
Your answer should be compact. 0. What is the ratio of the Debt(current US$) of Middle East & North Africa (developing only) in 1977 to that in 1980?
Provide a succinct answer. 0.6. What is the ratio of the Debt(current US$) in South Asia in 1977 to that in 1980?
Keep it short and to the point. 0.24. What is the ratio of the Debt(current US$) of Cameroon in 1977 to that in 1980?
Ensure brevity in your answer.  2.11. What is the ratio of the Debt(current US$) of Nigeria in 1977 to that in 1980?
Give a very brief answer. 0. What is the ratio of the Debt(current US$) of Middle East & North Africa (developing only) in 1978 to that in 1979?
Ensure brevity in your answer.  0.81. What is the ratio of the Debt(current US$) in South Asia in 1978 to that in 1979?
Make the answer very short. 0.67. What is the ratio of the Debt(current US$) in Cameroon in 1978 to that in 1979?
Provide a short and direct response. 0.68. What is the ratio of the Debt(current US$) in Nigeria in 1978 to that in 1979?
Your response must be concise. 0.17. What is the ratio of the Debt(current US$) in Middle East & North Africa (developing only) in 1978 to that in 1980?
Make the answer very short. 0.81. What is the ratio of the Debt(current US$) in South Asia in 1978 to that in 1980?
Offer a very short reply. 0.23. What is the ratio of the Debt(current US$) of Cameroon in 1978 to that in 1980?
Make the answer very short. 3.62. What is the ratio of the Debt(current US$) in Nigeria in 1978 to that in 1980?
Offer a terse response. 0.16. What is the ratio of the Debt(current US$) in South Asia in 1979 to that in 1980?
Keep it short and to the point. 0.34. What is the ratio of the Debt(current US$) of Cameroon in 1979 to that in 1980?
Your answer should be very brief. 5.32. What is the ratio of the Debt(current US$) of Nigeria in 1979 to that in 1980?
Make the answer very short. 0.94. What is the difference between the highest and the second highest Debt(current US$) in Middle East & North Africa (developing only)?
Offer a terse response. 1.97e+07. What is the difference between the highest and the second highest Debt(current US$) of South Asia?
Provide a short and direct response. 8.94e+08. What is the difference between the highest and the second highest Debt(current US$) of Cameroon?
Keep it short and to the point. 1.25e+08. What is the difference between the highest and the second highest Debt(current US$) in Nigeria?
Provide a succinct answer. 1.69e+08. What is the difference between the highest and the lowest Debt(current US$) in Middle East & North Africa (developing only)?
Your answer should be very brief. 9.13e+09. What is the difference between the highest and the lowest Debt(current US$) of South Asia?
Keep it short and to the point. 1.14e+09. What is the difference between the highest and the lowest Debt(current US$) of Cameroon?
Offer a very short reply. 3.46e+08. What is the difference between the highest and the lowest Debt(current US$) of Nigeria?
Your response must be concise. 2.61e+09. 